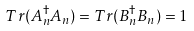<formula> <loc_0><loc_0><loc_500><loc_500>T r ( A _ { n } ^ { \dagger } A _ { n } ) = T r ( B _ { n } ^ { \dagger } B _ { n } ) = 1</formula> 